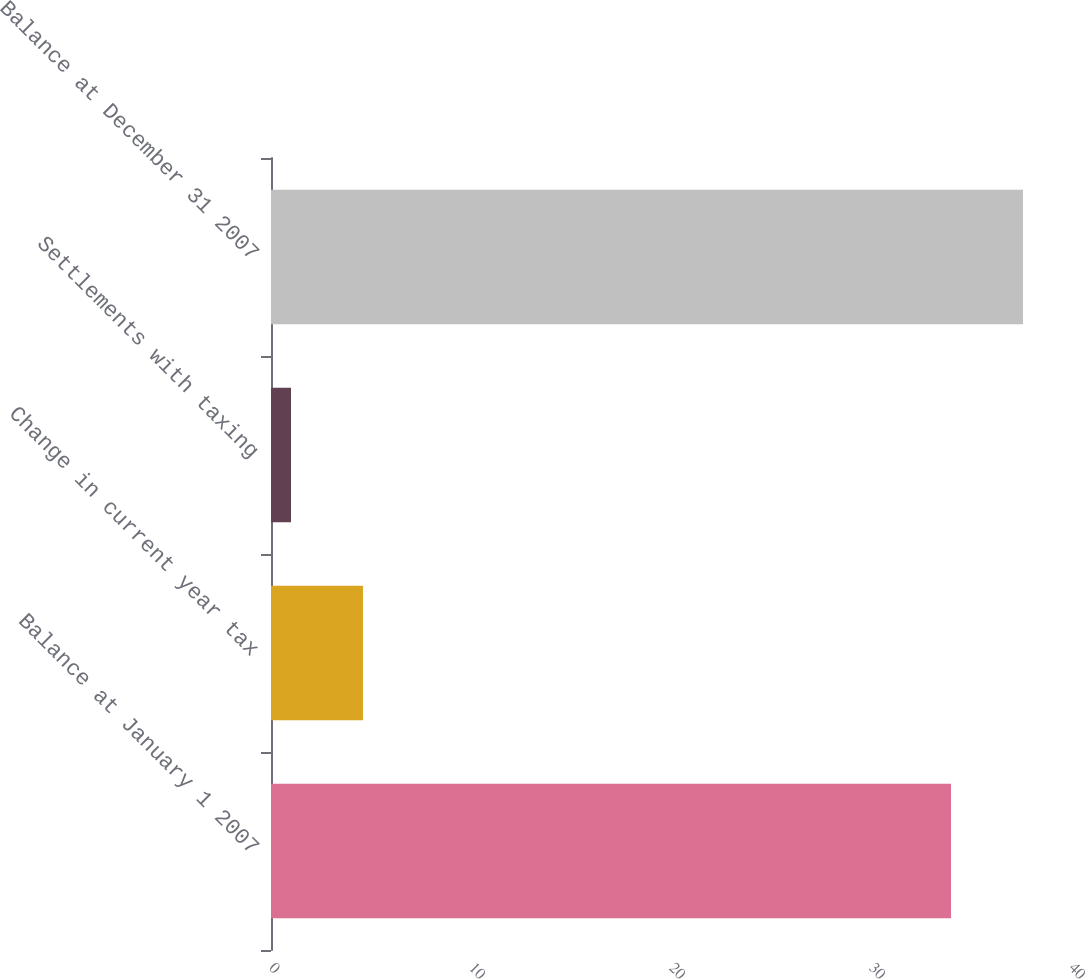Convert chart. <chart><loc_0><loc_0><loc_500><loc_500><bar_chart><fcel>Balance at January 1 2007<fcel>Change in current year tax<fcel>Settlements with taxing<fcel>Balance at December 31 2007<nl><fcel>34<fcel>4.6<fcel>1<fcel>37.6<nl></chart> 